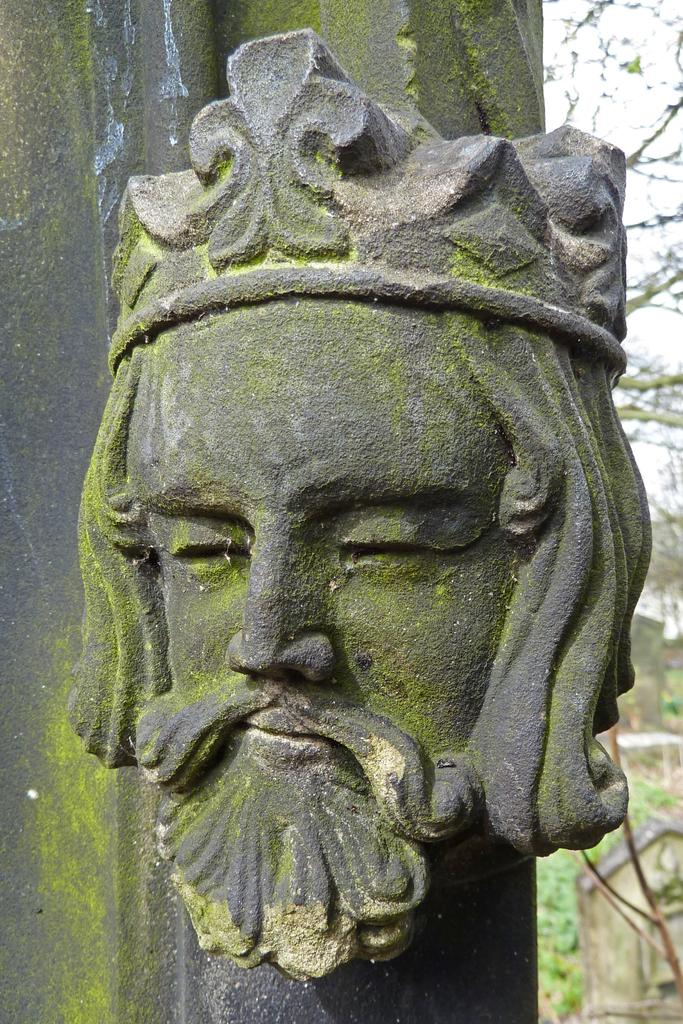What type of artwork is in the image? There is a stone sculpture in the image. What is the subject of the sculpture? The sculpture is of a man's face. What facial features does the man have? The man has a beard. What is the man wearing on his head? The man is wearing a crown. What can be seen in the background of the image? There are trees in the background of the image. What type of produce is the man holding in the image? There is no produce present in the image; the man is a stone sculpture and does not hold any items. What type of vacation destination is depicted in the image? The image does not depict a vacation destination; it features a stone sculpture of a man's face. 